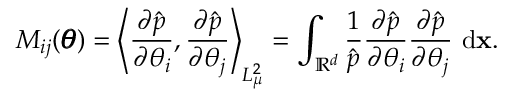<formula> <loc_0><loc_0><loc_500><loc_500>M _ { i j } ( \pm b \theta ) = \left \langle \frac { \partial \hat { p } } { \partial \theta _ { i } } , \frac { \partial \hat { p } } { \partial \theta _ { j } } \right \rangle _ { L _ { \mu } ^ { 2 } } = \int _ { \mathbb { R } ^ { d } } \frac { 1 } { \hat { p } } \frac { \partial \hat { p } } { \partial \theta _ { i } } \frac { \partial \hat { p } } { \partial \theta _ { j } } \ \mathrm d \mathbf x .</formula> 